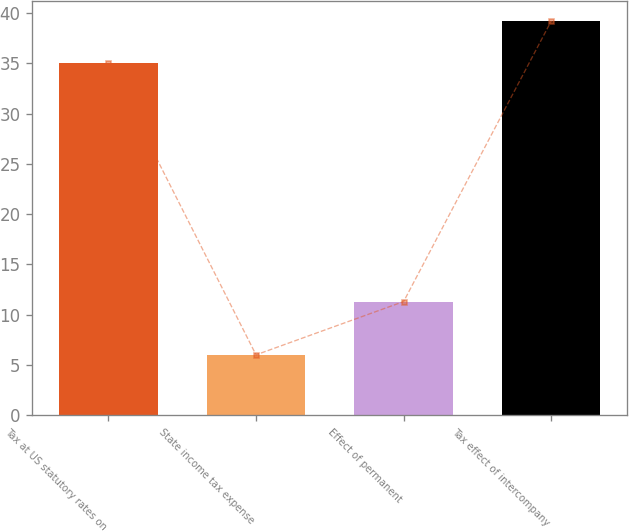Convert chart to OTSL. <chart><loc_0><loc_0><loc_500><loc_500><bar_chart><fcel>Tax at US statutory rates on<fcel>State income tax expense<fcel>Effect of permanent<fcel>Tax effect of intercompany<nl><fcel>35<fcel>6<fcel>11.3<fcel>39.2<nl></chart> 